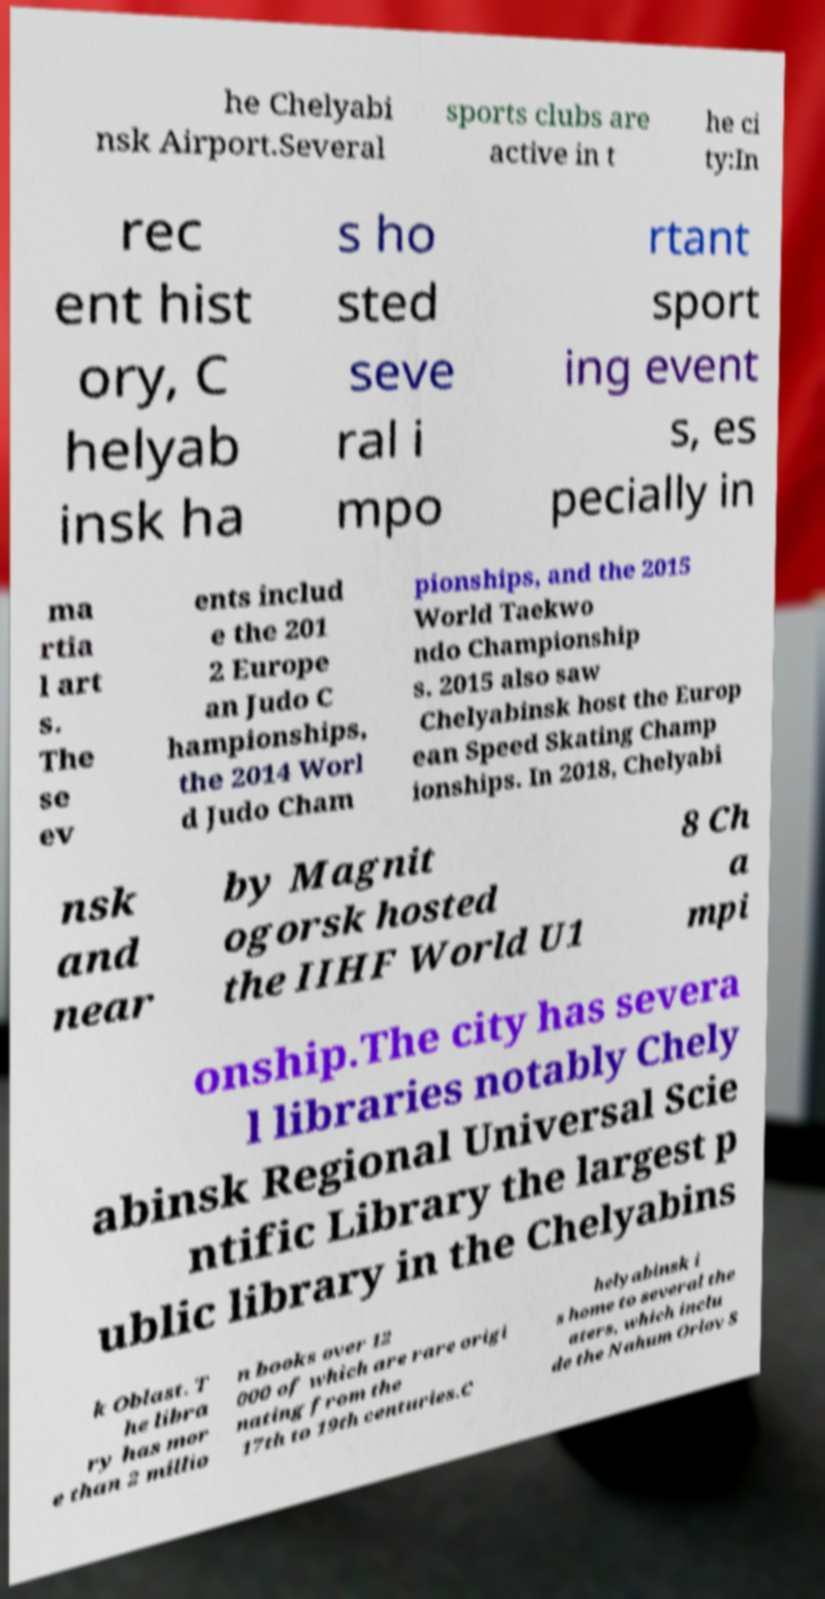Can you read and provide the text displayed in the image?This photo seems to have some interesting text. Can you extract and type it out for me? he Chelyabi nsk Airport.Several sports clubs are active in t he ci ty:In rec ent hist ory, C helyab insk ha s ho sted seve ral i mpo rtant sport ing event s, es pecially in ma rtia l art s. The se ev ents includ e the 201 2 Europe an Judo C hampionships, the 2014 Worl d Judo Cham pionships, and the 2015 World Taekwo ndo Championship s. 2015 also saw Chelyabinsk host the Europ ean Speed Skating Champ ionships. In 2018, Chelyabi nsk and near by Magnit ogorsk hosted the IIHF World U1 8 Ch a mpi onship.The city has severa l libraries notably Chely abinsk Regional Universal Scie ntific Library the largest p ublic library in the Chelyabins k Oblast. T he libra ry has mor e than 2 millio n books over 12 000 of which are rare origi nating from the 17th to 19th centuries.C helyabinsk i s home to several the aters, which inclu de the Nahum Orlov S 